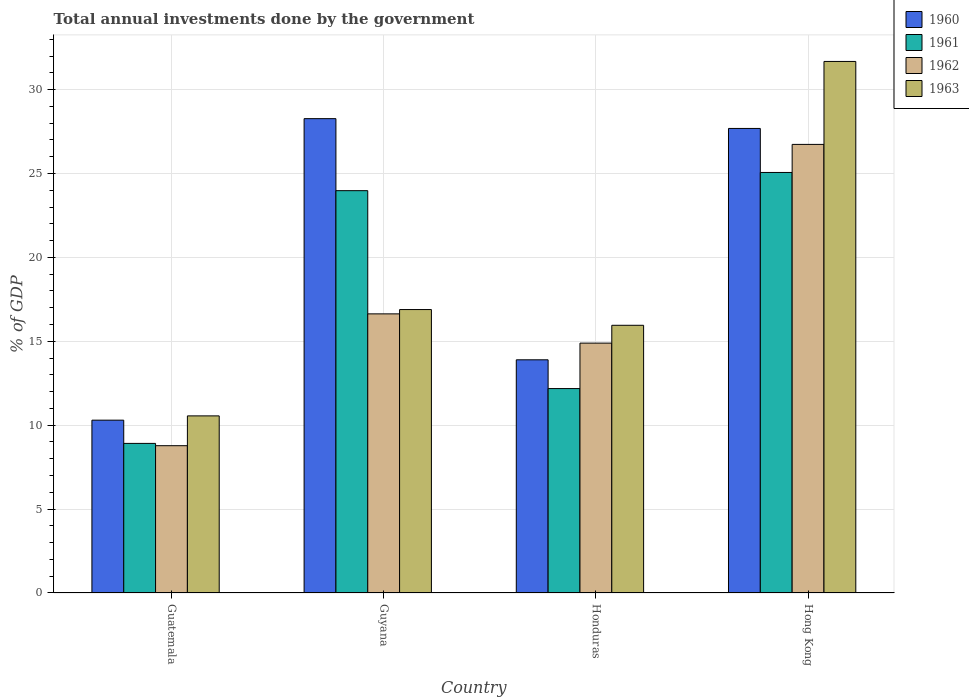How many different coloured bars are there?
Your answer should be compact. 4. Are the number of bars per tick equal to the number of legend labels?
Your answer should be compact. Yes. What is the label of the 3rd group of bars from the left?
Make the answer very short. Honduras. What is the total annual investments done by the government in 1960 in Guatemala?
Offer a very short reply. 10.3. Across all countries, what is the maximum total annual investments done by the government in 1961?
Your answer should be compact. 25.06. Across all countries, what is the minimum total annual investments done by the government in 1963?
Offer a very short reply. 10.56. In which country was the total annual investments done by the government in 1960 maximum?
Your answer should be compact. Guyana. In which country was the total annual investments done by the government in 1960 minimum?
Offer a very short reply. Guatemala. What is the total total annual investments done by the government in 1963 in the graph?
Offer a terse response. 75.09. What is the difference between the total annual investments done by the government in 1963 in Guatemala and that in Guyana?
Your answer should be very brief. -6.34. What is the difference between the total annual investments done by the government in 1961 in Guatemala and the total annual investments done by the government in 1962 in Honduras?
Ensure brevity in your answer.  -5.98. What is the average total annual investments done by the government in 1963 per country?
Make the answer very short. 18.77. What is the difference between the total annual investments done by the government of/in 1963 and total annual investments done by the government of/in 1961 in Guyana?
Offer a very short reply. -7.09. What is the ratio of the total annual investments done by the government in 1963 in Guyana to that in Honduras?
Provide a short and direct response. 1.06. What is the difference between the highest and the second highest total annual investments done by the government in 1961?
Your answer should be very brief. 12.88. What is the difference between the highest and the lowest total annual investments done by the government in 1960?
Offer a terse response. 17.97. Is the sum of the total annual investments done by the government in 1960 in Guatemala and Guyana greater than the maximum total annual investments done by the government in 1961 across all countries?
Your answer should be compact. Yes. Is it the case that in every country, the sum of the total annual investments done by the government in 1960 and total annual investments done by the government in 1963 is greater than the sum of total annual investments done by the government in 1961 and total annual investments done by the government in 1962?
Make the answer very short. No. What does the 1st bar from the left in Honduras represents?
Give a very brief answer. 1960. Is it the case that in every country, the sum of the total annual investments done by the government in 1960 and total annual investments done by the government in 1962 is greater than the total annual investments done by the government in 1961?
Offer a very short reply. Yes. How many bars are there?
Provide a succinct answer. 16. Are all the bars in the graph horizontal?
Provide a short and direct response. No. How many countries are there in the graph?
Ensure brevity in your answer.  4. What is the difference between two consecutive major ticks on the Y-axis?
Your answer should be compact. 5. Are the values on the major ticks of Y-axis written in scientific E-notation?
Ensure brevity in your answer.  No. Does the graph contain any zero values?
Keep it short and to the point. No. How many legend labels are there?
Offer a terse response. 4. How are the legend labels stacked?
Offer a terse response. Vertical. What is the title of the graph?
Offer a terse response. Total annual investments done by the government. What is the label or title of the Y-axis?
Provide a succinct answer. % of GDP. What is the % of GDP of 1960 in Guatemala?
Make the answer very short. 10.3. What is the % of GDP in 1961 in Guatemala?
Your answer should be compact. 8.92. What is the % of GDP of 1962 in Guatemala?
Keep it short and to the point. 8.78. What is the % of GDP of 1963 in Guatemala?
Your answer should be very brief. 10.56. What is the % of GDP in 1960 in Guyana?
Your response must be concise. 28.27. What is the % of GDP of 1961 in Guyana?
Offer a very short reply. 23.98. What is the % of GDP of 1962 in Guyana?
Provide a short and direct response. 16.64. What is the % of GDP in 1963 in Guyana?
Offer a very short reply. 16.89. What is the % of GDP of 1960 in Honduras?
Keep it short and to the point. 13.9. What is the % of GDP in 1961 in Honduras?
Offer a very short reply. 12.18. What is the % of GDP of 1962 in Honduras?
Provide a short and direct response. 14.89. What is the % of GDP of 1963 in Honduras?
Offer a very short reply. 15.96. What is the % of GDP in 1960 in Hong Kong?
Offer a very short reply. 27.69. What is the % of GDP of 1961 in Hong Kong?
Your answer should be compact. 25.06. What is the % of GDP of 1962 in Hong Kong?
Provide a succinct answer. 26.74. What is the % of GDP in 1963 in Hong Kong?
Provide a succinct answer. 31.68. Across all countries, what is the maximum % of GDP of 1960?
Your answer should be compact. 28.27. Across all countries, what is the maximum % of GDP in 1961?
Make the answer very short. 25.06. Across all countries, what is the maximum % of GDP in 1962?
Make the answer very short. 26.74. Across all countries, what is the maximum % of GDP of 1963?
Provide a succinct answer. 31.68. Across all countries, what is the minimum % of GDP of 1960?
Your answer should be very brief. 10.3. Across all countries, what is the minimum % of GDP of 1961?
Ensure brevity in your answer.  8.92. Across all countries, what is the minimum % of GDP in 1962?
Ensure brevity in your answer.  8.78. Across all countries, what is the minimum % of GDP in 1963?
Offer a terse response. 10.56. What is the total % of GDP in 1960 in the graph?
Provide a short and direct response. 80.16. What is the total % of GDP in 1961 in the graph?
Keep it short and to the point. 70.14. What is the total % of GDP in 1962 in the graph?
Ensure brevity in your answer.  67.05. What is the total % of GDP of 1963 in the graph?
Provide a succinct answer. 75.09. What is the difference between the % of GDP of 1960 in Guatemala and that in Guyana?
Offer a terse response. -17.97. What is the difference between the % of GDP of 1961 in Guatemala and that in Guyana?
Offer a very short reply. -15.06. What is the difference between the % of GDP in 1962 in Guatemala and that in Guyana?
Keep it short and to the point. -7.86. What is the difference between the % of GDP of 1963 in Guatemala and that in Guyana?
Your answer should be very brief. -6.34. What is the difference between the % of GDP of 1960 in Guatemala and that in Honduras?
Provide a short and direct response. -3.6. What is the difference between the % of GDP of 1961 in Guatemala and that in Honduras?
Ensure brevity in your answer.  -3.27. What is the difference between the % of GDP of 1962 in Guatemala and that in Honduras?
Provide a succinct answer. -6.11. What is the difference between the % of GDP of 1963 in Guatemala and that in Honduras?
Ensure brevity in your answer.  -5.4. What is the difference between the % of GDP of 1960 in Guatemala and that in Hong Kong?
Make the answer very short. -17.39. What is the difference between the % of GDP in 1961 in Guatemala and that in Hong Kong?
Give a very brief answer. -16.15. What is the difference between the % of GDP in 1962 in Guatemala and that in Hong Kong?
Offer a terse response. -17.96. What is the difference between the % of GDP in 1963 in Guatemala and that in Hong Kong?
Ensure brevity in your answer.  -21.13. What is the difference between the % of GDP of 1960 in Guyana and that in Honduras?
Ensure brevity in your answer.  14.37. What is the difference between the % of GDP in 1961 in Guyana and that in Honduras?
Provide a short and direct response. 11.8. What is the difference between the % of GDP in 1962 in Guyana and that in Honduras?
Provide a short and direct response. 1.74. What is the difference between the % of GDP of 1963 in Guyana and that in Honduras?
Your response must be concise. 0.94. What is the difference between the % of GDP in 1960 in Guyana and that in Hong Kong?
Offer a very short reply. 0.58. What is the difference between the % of GDP of 1961 in Guyana and that in Hong Kong?
Your answer should be very brief. -1.08. What is the difference between the % of GDP of 1962 in Guyana and that in Hong Kong?
Provide a short and direct response. -10.1. What is the difference between the % of GDP of 1963 in Guyana and that in Hong Kong?
Ensure brevity in your answer.  -14.79. What is the difference between the % of GDP in 1960 in Honduras and that in Hong Kong?
Provide a succinct answer. -13.79. What is the difference between the % of GDP of 1961 in Honduras and that in Hong Kong?
Your answer should be compact. -12.88. What is the difference between the % of GDP in 1962 in Honduras and that in Hong Kong?
Offer a very short reply. -11.84. What is the difference between the % of GDP of 1963 in Honduras and that in Hong Kong?
Ensure brevity in your answer.  -15.73. What is the difference between the % of GDP in 1960 in Guatemala and the % of GDP in 1961 in Guyana?
Provide a succinct answer. -13.68. What is the difference between the % of GDP of 1960 in Guatemala and the % of GDP of 1962 in Guyana?
Provide a short and direct response. -6.34. What is the difference between the % of GDP of 1960 in Guatemala and the % of GDP of 1963 in Guyana?
Your answer should be very brief. -6.59. What is the difference between the % of GDP in 1961 in Guatemala and the % of GDP in 1962 in Guyana?
Provide a succinct answer. -7.72. What is the difference between the % of GDP of 1961 in Guatemala and the % of GDP of 1963 in Guyana?
Offer a terse response. -7.98. What is the difference between the % of GDP in 1962 in Guatemala and the % of GDP in 1963 in Guyana?
Make the answer very short. -8.11. What is the difference between the % of GDP in 1960 in Guatemala and the % of GDP in 1961 in Honduras?
Provide a succinct answer. -1.88. What is the difference between the % of GDP in 1960 in Guatemala and the % of GDP in 1962 in Honduras?
Provide a short and direct response. -4.59. What is the difference between the % of GDP of 1960 in Guatemala and the % of GDP of 1963 in Honduras?
Make the answer very short. -5.65. What is the difference between the % of GDP in 1961 in Guatemala and the % of GDP in 1962 in Honduras?
Ensure brevity in your answer.  -5.98. What is the difference between the % of GDP of 1961 in Guatemala and the % of GDP of 1963 in Honduras?
Keep it short and to the point. -7.04. What is the difference between the % of GDP in 1962 in Guatemala and the % of GDP in 1963 in Honduras?
Your response must be concise. -7.18. What is the difference between the % of GDP of 1960 in Guatemala and the % of GDP of 1961 in Hong Kong?
Your response must be concise. -14.76. What is the difference between the % of GDP in 1960 in Guatemala and the % of GDP in 1962 in Hong Kong?
Give a very brief answer. -16.44. What is the difference between the % of GDP of 1960 in Guatemala and the % of GDP of 1963 in Hong Kong?
Make the answer very short. -21.38. What is the difference between the % of GDP of 1961 in Guatemala and the % of GDP of 1962 in Hong Kong?
Provide a succinct answer. -17.82. What is the difference between the % of GDP of 1961 in Guatemala and the % of GDP of 1963 in Hong Kong?
Your response must be concise. -22.77. What is the difference between the % of GDP of 1962 in Guatemala and the % of GDP of 1963 in Hong Kong?
Provide a short and direct response. -22.9. What is the difference between the % of GDP of 1960 in Guyana and the % of GDP of 1961 in Honduras?
Give a very brief answer. 16.09. What is the difference between the % of GDP of 1960 in Guyana and the % of GDP of 1962 in Honduras?
Your answer should be very brief. 13.38. What is the difference between the % of GDP in 1960 in Guyana and the % of GDP in 1963 in Honduras?
Your answer should be very brief. 12.32. What is the difference between the % of GDP of 1961 in Guyana and the % of GDP of 1962 in Honduras?
Offer a terse response. 9.09. What is the difference between the % of GDP in 1961 in Guyana and the % of GDP in 1963 in Honduras?
Your response must be concise. 8.02. What is the difference between the % of GDP in 1962 in Guyana and the % of GDP in 1963 in Honduras?
Your answer should be very brief. 0.68. What is the difference between the % of GDP in 1960 in Guyana and the % of GDP in 1961 in Hong Kong?
Your answer should be compact. 3.21. What is the difference between the % of GDP in 1960 in Guyana and the % of GDP in 1962 in Hong Kong?
Keep it short and to the point. 1.53. What is the difference between the % of GDP of 1960 in Guyana and the % of GDP of 1963 in Hong Kong?
Offer a very short reply. -3.41. What is the difference between the % of GDP in 1961 in Guyana and the % of GDP in 1962 in Hong Kong?
Your response must be concise. -2.76. What is the difference between the % of GDP of 1961 in Guyana and the % of GDP of 1963 in Hong Kong?
Offer a terse response. -7.7. What is the difference between the % of GDP in 1962 in Guyana and the % of GDP in 1963 in Hong Kong?
Provide a succinct answer. -15.04. What is the difference between the % of GDP in 1960 in Honduras and the % of GDP in 1961 in Hong Kong?
Offer a terse response. -11.17. What is the difference between the % of GDP in 1960 in Honduras and the % of GDP in 1962 in Hong Kong?
Ensure brevity in your answer.  -12.84. What is the difference between the % of GDP in 1960 in Honduras and the % of GDP in 1963 in Hong Kong?
Give a very brief answer. -17.78. What is the difference between the % of GDP in 1961 in Honduras and the % of GDP in 1962 in Hong Kong?
Ensure brevity in your answer.  -14.55. What is the difference between the % of GDP in 1961 in Honduras and the % of GDP in 1963 in Hong Kong?
Keep it short and to the point. -19.5. What is the difference between the % of GDP of 1962 in Honduras and the % of GDP of 1963 in Hong Kong?
Your answer should be very brief. -16.79. What is the average % of GDP in 1960 per country?
Offer a very short reply. 20.04. What is the average % of GDP of 1961 per country?
Your response must be concise. 17.54. What is the average % of GDP in 1962 per country?
Provide a short and direct response. 16.76. What is the average % of GDP in 1963 per country?
Your response must be concise. 18.77. What is the difference between the % of GDP in 1960 and % of GDP in 1961 in Guatemala?
Make the answer very short. 1.38. What is the difference between the % of GDP of 1960 and % of GDP of 1962 in Guatemala?
Give a very brief answer. 1.52. What is the difference between the % of GDP in 1960 and % of GDP in 1963 in Guatemala?
Ensure brevity in your answer.  -0.26. What is the difference between the % of GDP of 1961 and % of GDP of 1962 in Guatemala?
Offer a terse response. 0.14. What is the difference between the % of GDP of 1961 and % of GDP of 1963 in Guatemala?
Your answer should be very brief. -1.64. What is the difference between the % of GDP in 1962 and % of GDP in 1963 in Guatemala?
Provide a succinct answer. -1.78. What is the difference between the % of GDP in 1960 and % of GDP in 1961 in Guyana?
Your answer should be very brief. 4.29. What is the difference between the % of GDP of 1960 and % of GDP of 1962 in Guyana?
Offer a terse response. 11.64. What is the difference between the % of GDP in 1960 and % of GDP in 1963 in Guyana?
Your answer should be very brief. 11.38. What is the difference between the % of GDP of 1961 and % of GDP of 1962 in Guyana?
Provide a short and direct response. 7.34. What is the difference between the % of GDP in 1961 and % of GDP in 1963 in Guyana?
Your response must be concise. 7.09. What is the difference between the % of GDP of 1962 and % of GDP of 1963 in Guyana?
Make the answer very short. -0.26. What is the difference between the % of GDP in 1960 and % of GDP in 1961 in Honduras?
Your response must be concise. 1.71. What is the difference between the % of GDP of 1960 and % of GDP of 1962 in Honduras?
Give a very brief answer. -1. What is the difference between the % of GDP of 1960 and % of GDP of 1963 in Honduras?
Provide a succinct answer. -2.06. What is the difference between the % of GDP in 1961 and % of GDP in 1962 in Honduras?
Make the answer very short. -2.71. What is the difference between the % of GDP of 1961 and % of GDP of 1963 in Honduras?
Provide a short and direct response. -3.77. What is the difference between the % of GDP in 1962 and % of GDP in 1963 in Honduras?
Give a very brief answer. -1.06. What is the difference between the % of GDP in 1960 and % of GDP in 1961 in Hong Kong?
Keep it short and to the point. 2.62. What is the difference between the % of GDP in 1960 and % of GDP in 1962 in Hong Kong?
Your response must be concise. 0.95. What is the difference between the % of GDP in 1960 and % of GDP in 1963 in Hong Kong?
Your answer should be compact. -3.99. What is the difference between the % of GDP in 1961 and % of GDP in 1962 in Hong Kong?
Your answer should be very brief. -1.67. What is the difference between the % of GDP in 1961 and % of GDP in 1963 in Hong Kong?
Ensure brevity in your answer.  -6.62. What is the difference between the % of GDP of 1962 and % of GDP of 1963 in Hong Kong?
Make the answer very short. -4.94. What is the ratio of the % of GDP in 1960 in Guatemala to that in Guyana?
Keep it short and to the point. 0.36. What is the ratio of the % of GDP of 1961 in Guatemala to that in Guyana?
Your answer should be compact. 0.37. What is the ratio of the % of GDP of 1962 in Guatemala to that in Guyana?
Offer a very short reply. 0.53. What is the ratio of the % of GDP in 1963 in Guatemala to that in Guyana?
Provide a succinct answer. 0.62. What is the ratio of the % of GDP in 1960 in Guatemala to that in Honduras?
Offer a terse response. 0.74. What is the ratio of the % of GDP in 1961 in Guatemala to that in Honduras?
Provide a succinct answer. 0.73. What is the ratio of the % of GDP in 1962 in Guatemala to that in Honduras?
Your answer should be compact. 0.59. What is the ratio of the % of GDP in 1963 in Guatemala to that in Honduras?
Offer a very short reply. 0.66. What is the ratio of the % of GDP in 1960 in Guatemala to that in Hong Kong?
Provide a succinct answer. 0.37. What is the ratio of the % of GDP in 1961 in Guatemala to that in Hong Kong?
Give a very brief answer. 0.36. What is the ratio of the % of GDP in 1962 in Guatemala to that in Hong Kong?
Provide a succinct answer. 0.33. What is the ratio of the % of GDP in 1963 in Guatemala to that in Hong Kong?
Your answer should be compact. 0.33. What is the ratio of the % of GDP in 1960 in Guyana to that in Honduras?
Give a very brief answer. 2.03. What is the ratio of the % of GDP of 1961 in Guyana to that in Honduras?
Offer a terse response. 1.97. What is the ratio of the % of GDP of 1962 in Guyana to that in Honduras?
Keep it short and to the point. 1.12. What is the ratio of the % of GDP in 1963 in Guyana to that in Honduras?
Keep it short and to the point. 1.06. What is the ratio of the % of GDP of 1960 in Guyana to that in Hong Kong?
Your answer should be compact. 1.02. What is the ratio of the % of GDP in 1961 in Guyana to that in Hong Kong?
Give a very brief answer. 0.96. What is the ratio of the % of GDP of 1962 in Guyana to that in Hong Kong?
Offer a very short reply. 0.62. What is the ratio of the % of GDP of 1963 in Guyana to that in Hong Kong?
Your answer should be compact. 0.53. What is the ratio of the % of GDP in 1960 in Honduras to that in Hong Kong?
Provide a short and direct response. 0.5. What is the ratio of the % of GDP of 1961 in Honduras to that in Hong Kong?
Your response must be concise. 0.49. What is the ratio of the % of GDP in 1962 in Honduras to that in Hong Kong?
Ensure brevity in your answer.  0.56. What is the ratio of the % of GDP in 1963 in Honduras to that in Hong Kong?
Your answer should be very brief. 0.5. What is the difference between the highest and the second highest % of GDP of 1960?
Provide a succinct answer. 0.58. What is the difference between the highest and the second highest % of GDP of 1961?
Provide a succinct answer. 1.08. What is the difference between the highest and the second highest % of GDP of 1962?
Your answer should be very brief. 10.1. What is the difference between the highest and the second highest % of GDP in 1963?
Your answer should be compact. 14.79. What is the difference between the highest and the lowest % of GDP of 1960?
Your answer should be very brief. 17.97. What is the difference between the highest and the lowest % of GDP of 1961?
Give a very brief answer. 16.15. What is the difference between the highest and the lowest % of GDP in 1962?
Your answer should be compact. 17.96. What is the difference between the highest and the lowest % of GDP in 1963?
Give a very brief answer. 21.13. 